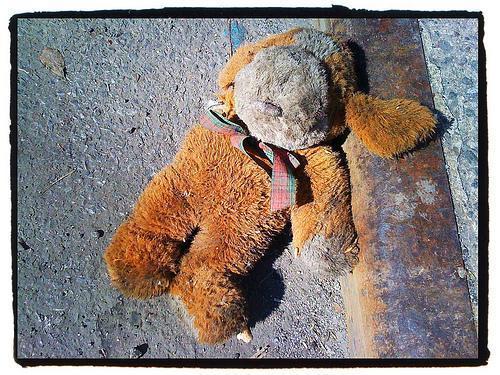How many arms can you see?
Give a very brief answer. 1. 